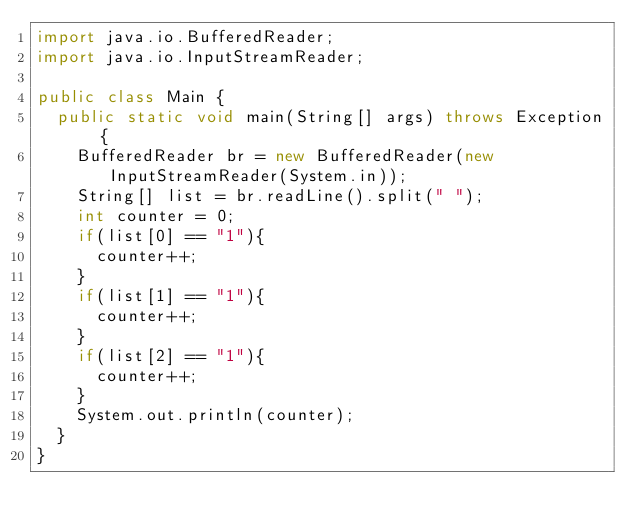Convert code to text. <code><loc_0><loc_0><loc_500><loc_500><_Java_>import java.io.BufferedReader;
import java.io.InputStreamReader;

public class Main {
	public static void main(String[] args) throws Exception {
		BufferedReader br = new BufferedReader(new InputStreamReader(System.in));
		String[] list = br.readLine().split(" ");
		int counter = 0;
		if(list[0] == "1"){
			counter++;
		}
		if(list[1] == "1"){
			counter++;
		}
		if(list[2] == "1"){
			counter++;
		}
		System.out.println(counter);
	}
}</code> 